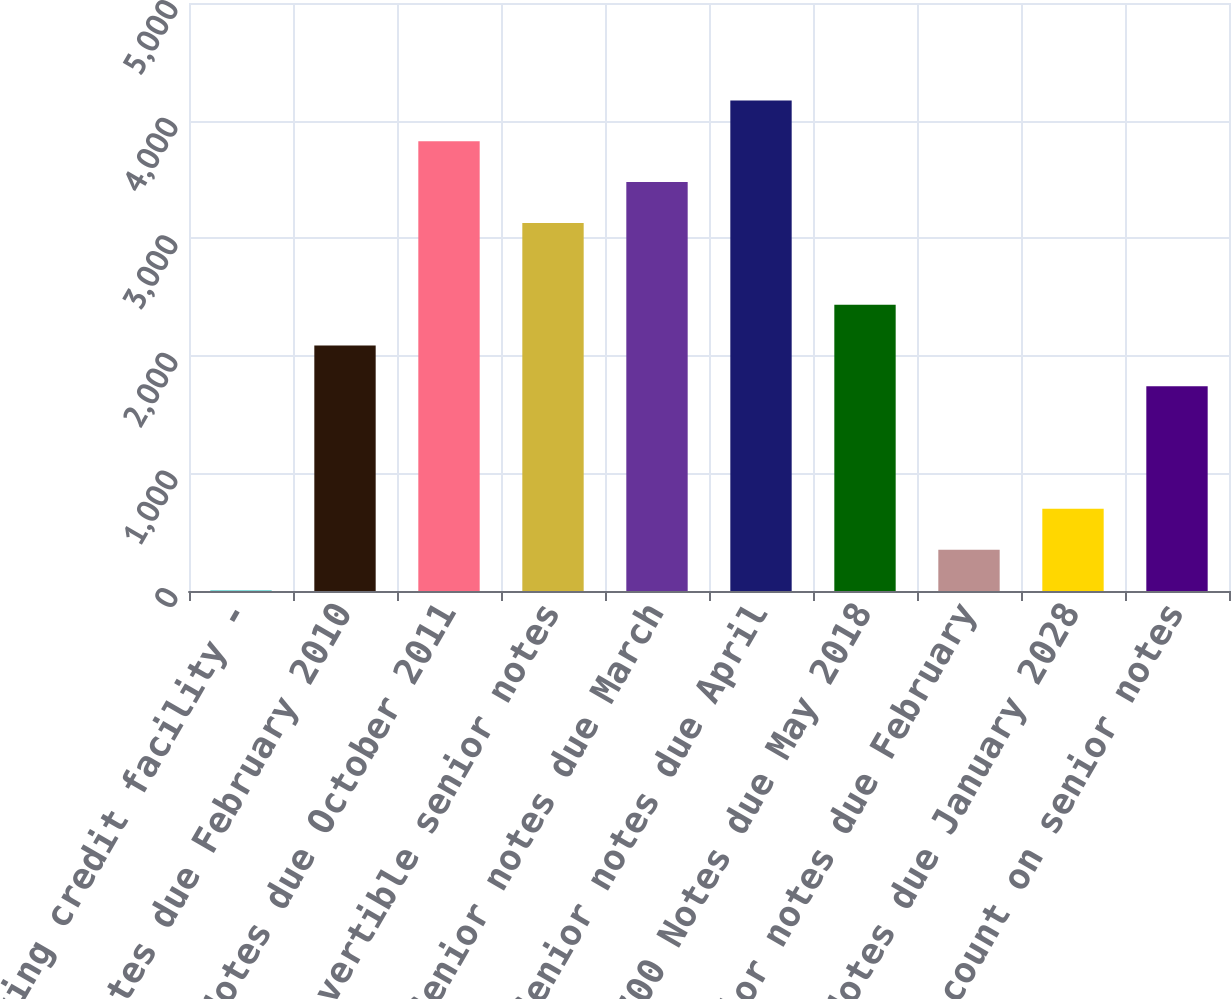<chart> <loc_0><loc_0><loc_500><loc_500><bar_chart><fcel>Revolving credit facility -<fcel>795 Notes due February 2010<fcel>825 Notes due October 2011<fcel>325 Convertible senior notes<fcel>1050 Senior notes due March<fcel>735 Senior notes due April<fcel>700 Notes due May 2018<fcel>7125 Senior notes due February<fcel>700 Notes due January 2028<fcel>Discount on senior notes<nl><fcel>4.19<fcel>2087.87<fcel>3824.27<fcel>3129.71<fcel>3476.99<fcel>4171.55<fcel>2435.15<fcel>351.47<fcel>698.75<fcel>1740.59<nl></chart> 